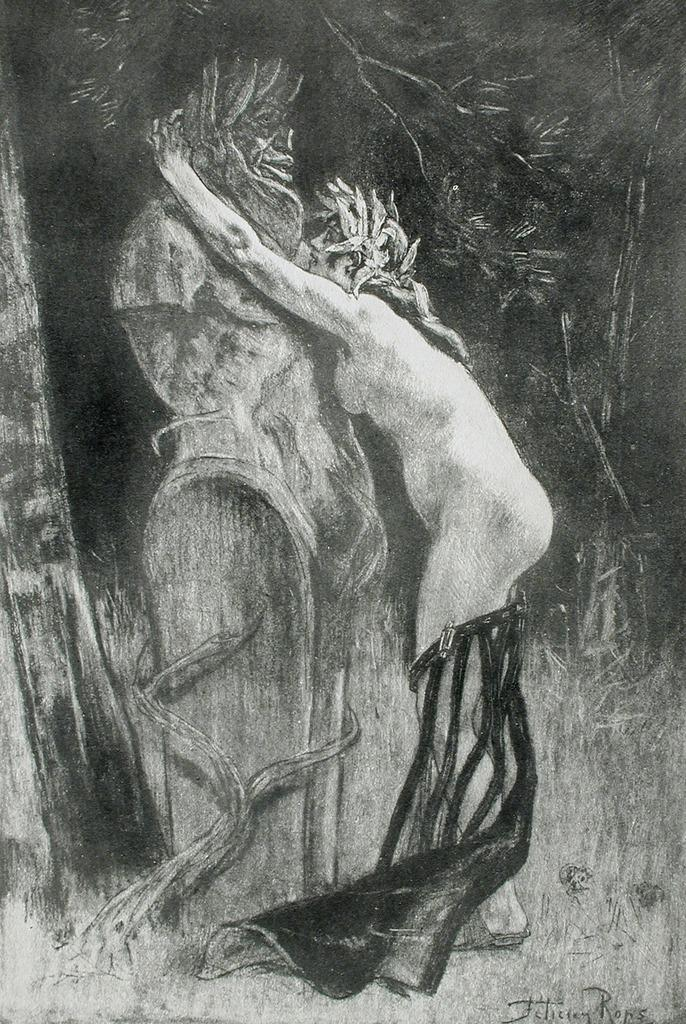What is the main subject of the image? There is an art piece in the image. Can you describe any additional details about the art piece? Unfortunately, the provided facts do not offer any additional details about the art piece. Is there any text present in the image? Yes, there is text in the bottom right corner of the image. What type of party is being held in the image? There is no party depicted in the image; it features an art piece and text. Can you describe the laughter of the people in the image? There are no people present in the image, and therefore no laughter can be observed. 